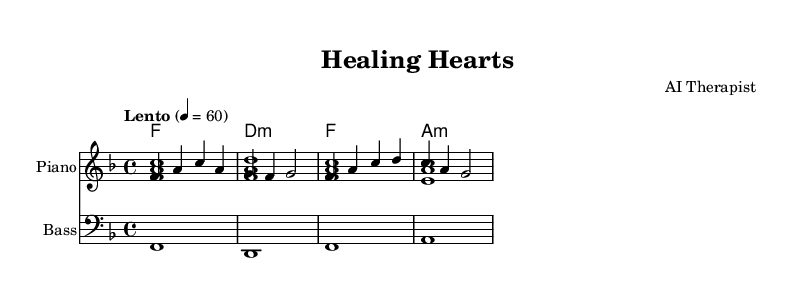What is the key signature of this music? The key signature is F major, which has one flat (B flat). This is indicated at the beginning of the staff, where the flat sign appears.
Answer: F major What is the time signature of this music? The time signature is 4/4, which indicates there are four beats in each measure and the quarter note receives one beat. This is typically notated at the beginning of the piece, right after the clef sign.
Answer: 4/4 What is the tempo marking of this music? The tempo marking is "Lento," which means slow. The specific BPM (beats per minute) is notated as 60, indicating a slow and comfortable pace.
Answer: Lento How many measures are in the piece? The piece consists of four measures, as each vertical line (bar line) represents the end of one measure and the beginning of another. Counting these lines confirms the total.
Answer: 4 What instrument is specified for the upper staff? The specified instrument for the upper staff is the Piano, noted in the instrument name at the start of the staff. It also indicates the type of sound expected (like an acoustic grand).
Answer: Piano What is the chord type used in the second measure? The chord type in the second measure is minor, as indicated by the "m" after the chord name, which denotes it is a diminished chord.
Answer: minor Why is "Healing Hearts" a suitable title for this dance? "Healing Hearts" suggests a theme of emotional reconnection and intimacy, which is appropriate for a romantic slow dance. The slow tempo and harmony reinforce this theme, promoting a relaxing and healing atmosphere during dance.
Answer: Healing Hearts 